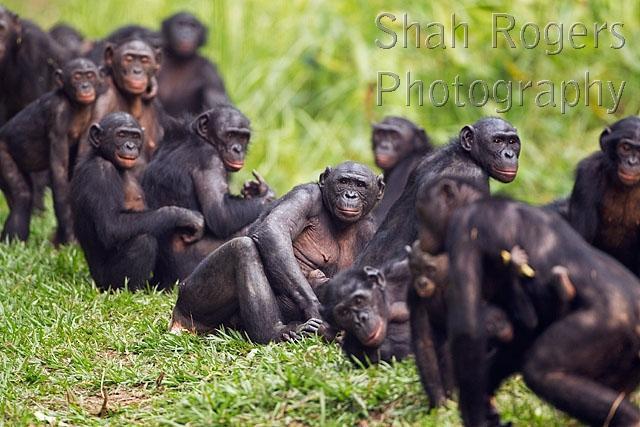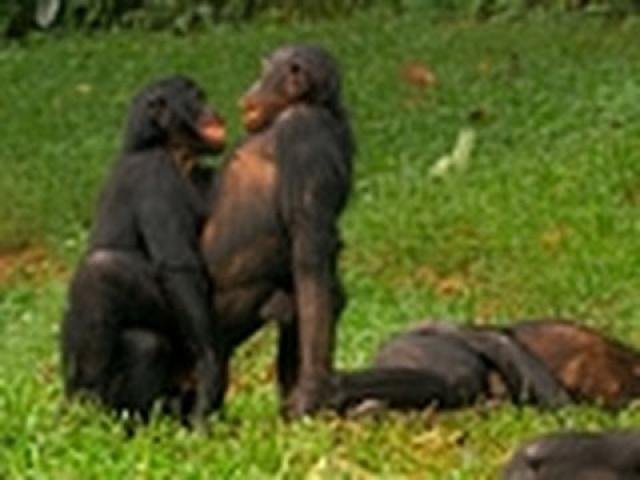The first image is the image on the left, the second image is the image on the right. Considering the images on both sides, is "The left image contains at least three chimpanzees." valid? Answer yes or no. Yes. The first image is the image on the left, the second image is the image on the right. Evaluate the accuracy of this statement regarding the images: "The baby monkey is staying close by the adult monkey.". Is it true? Answer yes or no. No. 